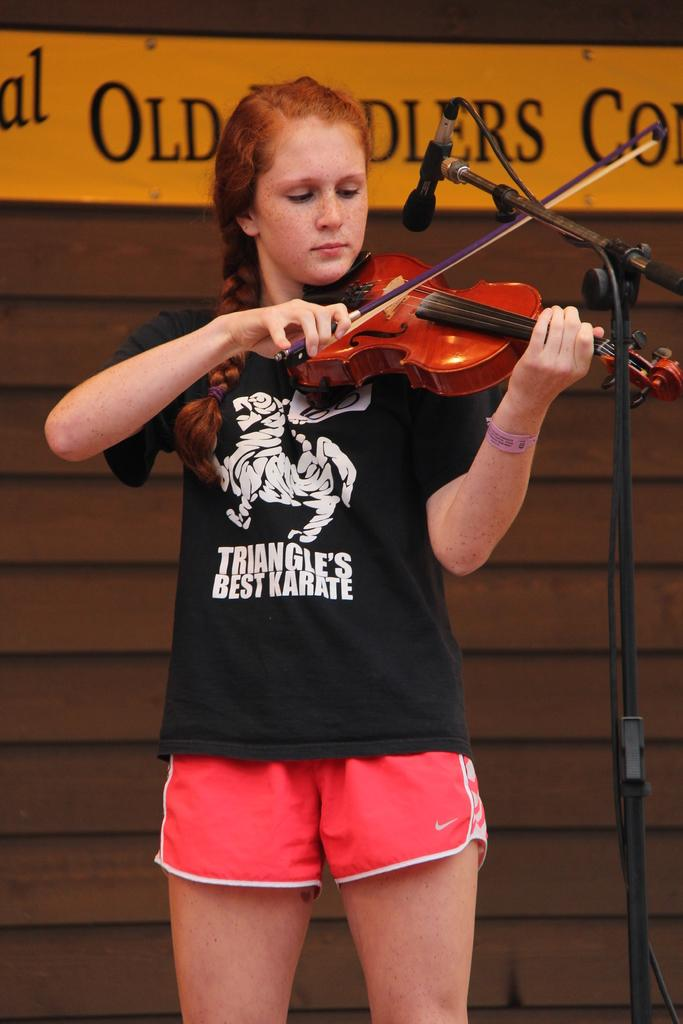<image>
Write a terse but informative summary of the picture. A girl is playing violin in black shirt that says "TRIANGLE'S BEST KARATE." 